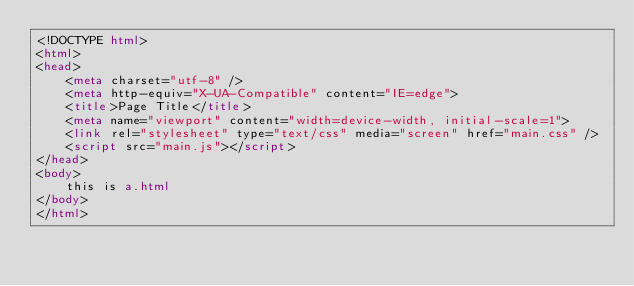Convert code to text. <code><loc_0><loc_0><loc_500><loc_500><_HTML_><!DOCTYPE html>
<html>
<head>
    <meta charset="utf-8" />
    <meta http-equiv="X-UA-Compatible" content="IE=edge">
    <title>Page Title</title>
    <meta name="viewport" content="width=device-width, initial-scale=1">
    <link rel="stylesheet" type="text/css" media="screen" href="main.css" />
    <script src="main.js"></script>
</head>
<body>
    this is a.html
</body>
</html></code> 